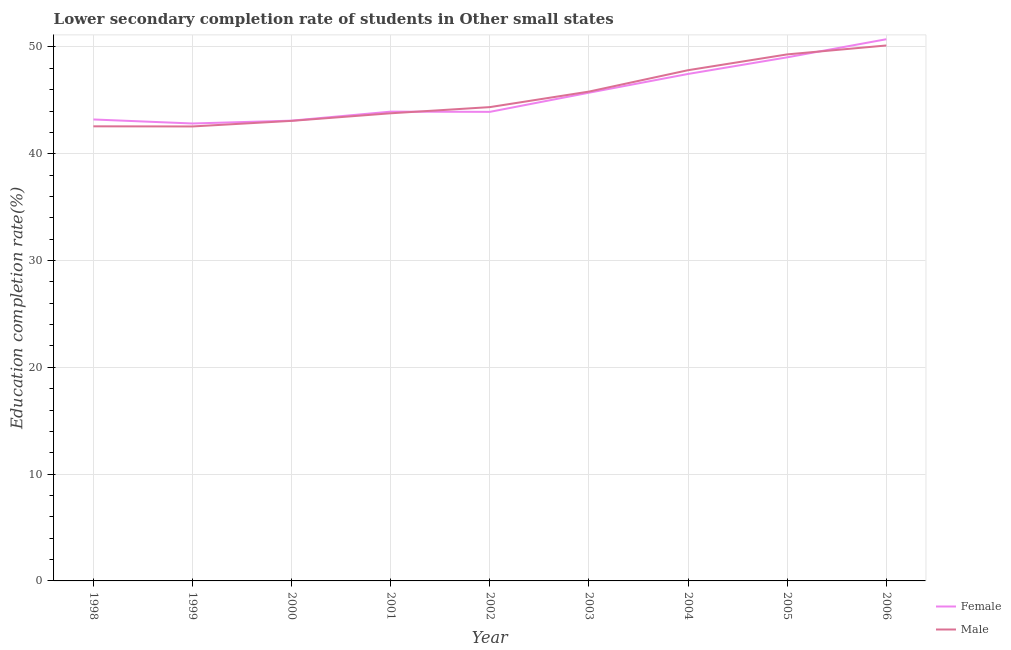How many different coloured lines are there?
Provide a succinct answer. 2. Does the line corresponding to education completion rate of female students intersect with the line corresponding to education completion rate of male students?
Make the answer very short. Yes. What is the education completion rate of female students in 1999?
Give a very brief answer. 42.84. Across all years, what is the maximum education completion rate of female students?
Offer a terse response. 50.72. Across all years, what is the minimum education completion rate of female students?
Keep it short and to the point. 42.84. What is the total education completion rate of female students in the graph?
Your answer should be very brief. 409.97. What is the difference between the education completion rate of female students in 2000 and that in 2002?
Make the answer very short. -0.82. What is the difference between the education completion rate of male students in 2003 and the education completion rate of female students in 2002?
Offer a terse response. 1.9. What is the average education completion rate of male students per year?
Your answer should be compact. 45.5. In the year 1999, what is the difference between the education completion rate of female students and education completion rate of male students?
Offer a terse response. 0.28. In how many years, is the education completion rate of female students greater than 40 %?
Ensure brevity in your answer.  9. What is the ratio of the education completion rate of male students in 2002 to that in 2004?
Provide a short and direct response. 0.93. Is the education completion rate of male students in 1998 less than that in 2004?
Provide a succinct answer. Yes. Is the difference between the education completion rate of male students in 2000 and 2001 greater than the difference between the education completion rate of female students in 2000 and 2001?
Make the answer very short. Yes. What is the difference between the highest and the second highest education completion rate of female students?
Provide a short and direct response. 1.69. What is the difference between the highest and the lowest education completion rate of female students?
Your answer should be compact. 7.89. In how many years, is the education completion rate of female students greater than the average education completion rate of female students taken over all years?
Ensure brevity in your answer.  4. Does the education completion rate of male students monotonically increase over the years?
Keep it short and to the point. No. Is the education completion rate of male students strictly greater than the education completion rate of female students over the years?
Offer a very short reply. No. Is the education completion rate of male students strictly less than the education completion rate of female students over the years?
Keep it short and to the point. No. Where does the legend appear in the graph?
Offer a terse response. Bottom right. What is the title of the graph?
Offer a very short reply. Lower secondary completion rate of students in Other small states. Does "Register a property" appear as one of the legend labels in the graph?
Ensure brevity in your answer.  No. What is the label or title of the Y-axis?
Give a very brief answer. Education completion rate(%). What is the Education completion rate(%) of Female in 1998?
Make the answer very short. 43.21. What is the Education completion rate(%) of Male in 1998?
Offer a very short reply. 42.57. What is the Education completion rate(%) of Female in 1999?
Give a very brief answer. 42.84. What is the Education completion rate(%) of Male in 1999?
Offer a very short reply. 42.56. What is the Education completion rate(%) of Female in 2000?
Your answer should be compact. 43.1. What is the Education completion rate(%) in Male in 2000?
Your answer should be compact. 43.08. What is the Education completion rate(%) of Female in 2001?
Provide a succinct answer. 43.95. What is the Education completion rate(%) in Male in 2001?
Give a very brief answer. 43.79. What is the Education completion rate(%) in Female in 2002?
Make the answer very short. 43.92. What is the Education completion rate(%) in Male in 2002?
Provide a succinct answer. 44.37. What is the Education completion rate(%) in Female in 2003?
Give a very brief answer. 45.72. What is the Education completion rate(%) of Male in 2003?
Your answer should be very brief. 45.82. What is the Education completion rate(%) in Female in 2004?
Your answer should be very brief. 47.47. What is the Education completion rate(%) of Male in 2004?
Give a very brief answer. 47.83. What is the Education completion rate(%) of Female in 2005?
Ensure brevity in your answer.  49.03. What is the Education completion rate(%) of Male in 2005?
Ensure brevity in your answer.  49.31. What is the Education completion rate(%) of Female in 2006?
Your answer should be compact. 50.72. What is the Education completion rate(%) of Male in 2006?
Your response must be concise. 50.14. Across all years, what is the maximum Education completion rate(%) in Female?
Offer a terse response. 50.72. Across all years, what is the maximum Education completion rate(%) of Male?
Provide a short and direct response. 50.14. Across all years, what is the minimum Education completion rate(%) in Female?
Your answer should be very brief. 42.84. Across all years, what is the minimum Education completion rate(%) of Male?
Provide a succinct answer. 42.56. What is the total Education completion rate(%) of Female in the graph?
Make the answer very short. 409.97. What is the total Education completion rate(%) in Male in the graph?
Ensure brevity in your answer.  409.46. What is the difference between the Education completion rate(%) of Female in 1998 and that in 1999?
Ensure brevity in your answer.  0.38. What is the difference between the Education completion rate(%) of Male in 1998 and that in 1999?
Your answer should be compact. 0.01. What is the difference between the Education completion rate(%) in Female in 1998 and that in 2000?
Your response must be concise. 0.11. What is the difference between the Education completion rate(%) of Male in 1998 and that in 2000?
Ensure brevity in your answer.  -0.51. What is the difference between the Education completion rate(%) of Female in 1998 and that in 2001?
Your answer should be compact. -0.73. What is the difference between the Education completion rate(%) of Male in 1998 and that in 2001?
Offer a very short reply. -1.22. What is the difference between the Education completion rate(%) in Female in 1998 and that in 2002?
Make the answer very short. -0.71. What is the difference between the Education completion rate(%) in Male in 1998 and that in 2002?
Give a very brief answer. -1.8. What is the difference between the Education completion rate(%) of Female in 1998 and that in 2003?
Your answer should be very brief. -2.51. What is the difference between the Education completion rate(%) in Male in 1998 and that in 2003?
Provide a short and direct response. -3.25. What is the difference between the Education completion rate(%) in Female in 1998 and that in 2004?
Offer a terse response. -4.26. What is the difference between the Education completion rate(%) of Male in 1998 and that in 2004?
Provide a succinct answer. -5.26. What is the difference between the Education completion rate(%) of Female in 1998 and that in 2005?
Make the answer very short. -5.82. What is the difference between the Education completion rate(%) of Male in 1998 and that in 2005?
Ensure brevity in your answer.  -6.74. What is the difference between the Education completion rate(%) in Female in 1998 and that in 2006?
Ensure brevity in your answer.  -7.51. What is the difference between the Education completion rate(%) in Male in 1998 and that in 2006?
Give a very brief answer. -7.57. What is the difference between the Education completion rate(%) in Female in 1999 and that in 2000?
Keep it short and to the point. -0.27. What is the difference between the Education completion rate(%) in Male in 1999 and that in 2000?
Make the answer very short. -0.52. What is the difference between the Education completion rate(%) in Female in 1999 and that in 2001?
Offer a very short reply. -1.11. What is the difference between the Education completion rate(%) of Male in 1999 and that in 2001?
Your answer should be compact. -1.23. What is the difference between the Education completion rate(%) in Female in 1999 and that in 2002?
Offer a very short reply. -1.09. What is the difference between the Education completion rate(%) in Male in 1999 and that in 2002?
Your response must be concise. -1.81. What is the difference between the Education completion rate(%) of Female in 1999 and that in 2003?
Your answer should be compact. -2.88. What is the difference between the Education completion rate(%) in Male in 1999 and that in 2003?
Give a very brief answer. -3.26. What is the difference between the Education completion rate(%) in Female in 1999 and that in 2004?
Give a very brief answer. -4.64. What is the difference between the Education completion rate(%) in Male in 1999 and that in 2004?
Make the answer very short. -5.27. What is the difference between the Education completion rate(%) in Female in 1999 and that in 2005?
Your answer should be compact. -6.2. What is the difference between the Education completion rate(%) in Male in 1999 and that in 2005?
Make the answer very short. -6.75. What is the difference between the Education completion rate(%) of Female in 1999 and that in 2006?
Your response must be concise. -7.89. What is the difference between the Education completion rate(%) of Male in 1999 and that in 2006?
Give a very brief answer. -7.58. What is the difference between the Education completion rate(%) in Female in 2000 and that in 2001?
Your answer should be compact. -0.84. What is the difference between the Education completion rate(%) in Male in 2000 and that in 2001?
Your answer should be compact. -0.71. What is the difference between the Education completion rate(%) of Female in 2000 and that in 2002?
Provide a short and direct response. -0.82. What is the difference between the Education completion rate(%) of Male in 2000 and that in 2002?
Offer a terse response. -1.29. What is the difference between the Education completion rate(%) in Female in 2000 and that in 2003?
Your response must be concise. -2.62. What is the difference between the Education completion rate(%) in Male in 2000 and that in 2003?
Offer a terse response. -2.74. What is the difference between the Education completion rate(%) of Female in 2000 and that in 2004?
Offer a terse response. -4.37. What is the difference between the Education completion rate(%) of Male in 2000 and that in 2004?
Provide a succinct answer. -4.75. What is the difference between the Education completion rate(%) in Female in 2000 and that in 2005?
Keep it short and to the point. -5.93. What is the difference between the Education completion rate(%) in Male in 2000 and that in 2005?
Offer a very short reply. -6.22. What is the difference between the Education completion rate(%) in Female in 2000 and that in 2006?
Give a very brief answer. -7.62. What is the difference between the Education completion rate(%) of Male in 2000 and that in 2006?
Provide a short and direct response. -7.06. What is the difference between the Education completion rate(%) in Female in 2001 and that in 2002?
Ensure brevity in your answer.  0.02. What is the difference between the Education completion rate(%) of Male in 2001 and that in 2002?
Your response must be concise. -0.58. What is the difference between the Education completion rate(%) of Female in 2001 and that in 2003?
Your answer should be very brief. -1.77. What is the difference between the Education completion rate(%) of Male in 2001 and that in 2003?
Provide a succinct answer. -2.03. What is the difference between the Education completion rate(%) of Female in 2001 and that in 2004?
Your answer should be compact. -3.53. What is the difference between the Education completion rate(%) of Male in 2001 and that in 2004?
Offer a very short reply. -4.03. What is the difference between the Education completion rate(%) in Female in 2001 and that in 2005?
Ensure brevity in your answer.  -5.09. What is the difference between the Education completion rate(%) in Male in 2001 and that in 2005?
Offer a very short reply. -5.51. What is the difference between the Education completion rate(%) in Female in 2001 and that in 2006?
Give a very brief answer. -6.78. What is the difference between the Education completion rate(%) of Male in 2001 and that in 2006?
Your answer should be compact. -6.35. What is the difference between the Education completion rate(%) of Female in 2002 and that in 2003?
Your answer should be very brief. -1.79. What is the difference between the Education completion rate(%) in Male in 2002 and that in 2003?
Your response must be concise. -1.45. What is the difference between the Education completion rate(%) in Female in 2002 and that in 2004?
Your answer should be very brief. -3.55. What is the difference between the Education completion rate(%) of Male in 2002 and that in 2004?
Provide a succinct answer. -3.46. What is the difference between the Education completion rate(%) of Female in 2002 and that in 2005?
Keep it short and to the point. -5.11. What is the difference between the Education completion rate(%) of Male in 2002 and that in 2005?
Offer a very short reply. -4.94. What is the difference between the Education completion rate(%) of Female in 2002 and that in 2006?
Ensure brevity in your answer.  -6.8. What is the difference between the Education completion rate(%) in Male in 2002 and that in 2006?
Provide a succinct answer. -5.77. What is the difference between the Education completion rate(%) in Female in 2003 and that in 2004?
Your answer should be compact. -1.76. What is the difference between the Education completion rate(%) in Male in 2003 and that in 2004?
Keep it short and to the point. -2. What is the difference between the Education completion rate(%) in Female in 2003 and that in 2005?
Offer a terse response. -3.31. What is the difference between the Education completion rate(%) in Male in 2003 and that in 2005?
Keep it short and to the point. -3.48. What is the difference between the Education completion rate(%) in Female in 2003 and that in 2006?
Offer a very short reply. -5.01. What is the difference between the Education completion rate(%) in Male in 2003 and that in 2006?
Provide a succinct answer. -4.32. What is the difference between the Education completion rate(%) in Female in 2004 and that in 2005?
Provide a succinct answer. -1.56. What is the difference between the Education completion rate(%) of Male in 2004 and that in 2005?
Provide a succinct answer. -1.48. What is the difference between the Education completion rate(%) of Female in 2004 and that in 2006?
Provide a succinct answer. -3.25. What is the difference between the Education completion rate(%) in Male in 2004 and that in 2006?
Offer a very short reply. -2.31. What is the difference between the Education completion rate(%) in Female in 2005 and that in 2006?
Provide a succinct answer. -1.69. What is the difference between the Education completion rate(%) of Male in 2005 and that in 2006?
Provide a short and direct response. -0.84. What is the difference between the Education completion rate(%) of Female in 1998 and the Education completion rate(%) of Male in 1999?
Provide a short and direct response. 0.65. What is the difference between the Education completion rate(%) of Female in 1998 and the Education completion rate(%) of Male in 2000?
Keep it short and to the point. 0.13. What is the difference between the Education completion rate(%) of Female in 1998 and the Education completion rate(%) of Male in 2001?
Offer a terse response. -0.58. What is the difference between the Education completion rate(%) of Female in 1998 and the Education completion rate(%) of Male in 2002?
Your response must be concise. -1.16. What is the difference between the Education completion rate(%) in Female in 1998 and the Education completion rate(%) in Male in 2003?
Ensure brevity in your answer.  -2.61. What is the difference between the Education completion rate(%) in Female in 1998 and the Education completion rate(%) in Male in 2004?
Your answer should be compact. -4.61. What is the difference between the Education completion rate(%) of Female in 1998 and the Education completion rate(%) of Male in 2005?
Offer a terse response. -6.09. What is the difference between the Education completion rate(%) in Female in 1998 and the Education completion rate(%) in Male in 2006?
Offer a very short reply. -6.93. What is the difference between the Education completion rate(%) of Female in 1999 and the Education completion rate(%) of Male in 2000?
Make the answer very short. -0.25. What is the difference between the Education completion rate(%) of Female in 1999 and the Education completion rate(%) of Male in 2001?
Keep it short and to the point. -0.96. What is the difference between the Education completion rate(%) in Female in 1999 and the Education completion rate(%) in Male in 2002?
Offer a very short reply. -1.53. What is the difference between the Education completion rate(%) in Female in 1999 and the Education completion rate(%) in Male in 2003?
Give a very brief answer. -2.99. What is the difference between the Education completion rate(%) of Female in 1999 and the Education completion rate(%) of Male in 2004?
Offer a terse response. -4.99. What is the difference between the Education completion rate(%) of Female in 1999 and the Education completion rate(%) of Male in 2005?
Provide a succinct answer. -6.47. What is the difference between the Education completion rate(%) in Female in 1999 and the Education completion rate(%) in Male in 2006?
Offer a very short reply. -7.31. What is the difference between the Education completion rate(%) in Female in 2000 and the Education completion rate(%) in Male in 2001?
Keep it short and to the point. -0.69. What is the difference between the Education completion rate(%) in Female in 2000 and the Education completion rate(%) in Male in 2002?
Ensure brevity in your answer.  -1.27. What is the difference between the Education completion rate(%) of Female in 2000 and the Education completion rate(%) of Male in 2003?
Give a very brief answer. -2.72. What is the difference between the Education completion rate(%) of Female in 2000 and the Education completion rate(%) of Male in 2004?
Provide a succinct answer. -4.73. What is the difference between the Education completion rate(%) of Female in 2000 and the Education completion rate(%) of Male in 2005?
Make the answer very short. -6.2. What is the difference between the Education completion rate(%) of Female in 2000 and the Education completion rate(%) of Male in 2006?
Provide a succinct answer. -7.04. What is the difference between the Education completion rate(%) of Female in 2001 and the Education completion rate(%) of Male in 2002?
Provide a succinct answer. -0.42. What is the difference between the Education completion rate(%) of Female in 2001 and the Education completion rate(%) of Male in 2003?
Ensure brevity in your answer.  -1.88. What is the difference between the Education completion rate(%) in Female in 2001 and the Education completion rate(%) in Male in 2004?
Your response must be concise. -3.88. What is the difference between the Education completion rate(%) in Female in 2001 and the Education completion rate(%) in Male in 2005?
Offer a very short reply. -5.36. What is the difference between the Education completion rate(%) in Female in 2001 and the Education completion rate(%) in Male in 2006?
Keep it short and to the point. -6.2. What is the difference between the Education completion rate(%) in Female in 2002 and the Education completion rate(%) in Male in 2003?
Provide a short and direct response. -1.9. What is the difference between the Education completion rate(%) in Female in 2002 and the Education completion rate(%) in Male in 2004?
Provide a short and direct response. -3.9. What is the difference between the Education completion rate(%) in Female in 2002 and the Education completion rate(%) in Male in 2005?
Give a very brief answer. -5.38. What is the difference between the Education completion rate(%) of Female in 2002 and the Education completion rate(%) of Male in 2006?
Give a very brief answer. -6.22. What is the difference between the Education completion rate(%) of Female in 2003 and the Education completion rate(%) of Male in 2004?
Ensure brevity in your answer.  -2.11. What is the difference between the Education completion rate(%) in Female in 2003 and the Education completion rate(%) in Male in 2005?
Give a very brief answer. -3.59. What is the difference between the Education completion rate(%) in Female in 2003 and the Education completion rate(%) in Male in 2006?
Your answer should be very brief. -4.42. What is the difference between the Education completion rate(%) of Female in 2004 and the Education completion rate(%) of Male in 2005?
Offer a terse response. -1.83. What is the difference between the Education completion rate(%) in Female in 2004 and the Education completion rate(%) in Male in 2006?
Your answer should be compact. -2.67. What is the difference between the Education completion rate(%) in Female in 2005 and the Education completion rate(%) in Male in 2006?
Offer a very short reply. -1.11. What is the average Education completion rate(%) of Female per year?
Your response must be concise. 45.55. What is the average Education completion rate(%) of Male per year?
Offer a very short reply. 45.5. In the year 1998, what is the difference between the Education completion rate(%) in Female and Education completion rate(%) in Male?
Keep it short and to the point. 0.64. In the year 1999, what is the difference between the Education completion rate(%) of Female and Education completion rate(%) of Male?
Provide a short and direct response. 0.28. In the year 2000, what is the difference between the Education completion rate(%) of Female and Education completion rate(%) of Male?
Keep it short and to the point. 0.02. In the year 2001, what is the difference between the Education completion rate(%) in Female and Education completion rate(%) in Male?
Provide a short and direct response. 0.15. In the year 2002, what is the difference between the Education completion rate(%) in Female and Education completion rate(%) in Male?
Provide a succinct answer. -0.44. In the year 2003, what is the difference between the Education completion rate(%) of Female and Education completion rate(%) of Male?
Offer a terse response. -0.1. In the year 2004, what is the difference between the Education completion rate(%) of Female and Education completion rate(%) of Male?
Offer a very short reply. -0.35. In the year 2005, what is the difference between the Education completion rate(%) in Female and Education completion rate(%) in Male?
Keep it short and to the point. -0.27. In the year 2006, what is the difference between the Education completion rate(%) of Female and Education completion rate(%) of Male?
Your answer should be compact. 0.58. What is the ratio of the Education completion rate(%) in Female in 1998 to that in 1999?
Your answer should be very brief. 1.01. What is the ratio of the Education completion rate(%) of Female in 1998 to that in 2001?
Provide a short and direct response. 0.98. What is the ratio of the Education completion rate(%) of Male in 1998 to that in 2001?
Your answer should be very brief. 0.97. What is the ratio of the Education completion rate(%) of Female in 1998 to that in 2002?
Keep it short and to the point. 0.98. What is the ratio of the Education completion rate(%) of Male in 1998 to that in 2002?
Offer a very short reply. 0.96. What is the ratio of the Education completion rate(%) in Female in 1998 to that in 2003?
Your response must be concise. 0.95. What is the ratio of the Education completion rate(%) in Male in 1998 to that in 2003?
Make the answer very short. 0.93. What is the ratio of the Education completion rate(%) of Female in 1998 to that in 2004?
Provide a short and direct response. 0.91. What is the ratio of the Education completion rate(%) in Male in 1998 to that in 2004?
Your response must be concise. 0.89. What is the ratio of the Education completion rate(%) in Female in 1998 to that in 2005?
Provide a short and direct response. 0.88. What is the ratio of the Education completion rate(%) in Male in 1998 to that in 2005?
Provide a short and direct response. 0.86. What is the ratio of the Education completion rate(%) in Female in 1998 to that in 2006?
Make the answer very short. 0.85. What is the ratio of the Education completion rate(%) in Male in 1998 to that in 2006?
Provide a succinct answer. 0.85. What is the ratio of the Education completion rate(%) of Female in 1999 to that in 2000?
Keep it short and to the point. 0.99. What is the ratio of the Education completion rate(%) of Male in 1999 to that in 2000?
Offer a very short reply. 0.99. What is the ratio of the Education completion rate(%) in Female in 1999 to that in 2001?
Offer a terse response. 0.97. What is the ratio of the Education completion rate(%) in Male in 1999 to that in 2001?
Offer a very short reply. 0.97. What is the ratio of the Education completion rate(%) of Female in 1999 to that in 2002?
Provide a succinct answer. 0.98. What is the ratio of the Education completion rate(%) of Male in 1999 to that in 2002?
Keep it short and to the point. 0.96. What is the ratio of the Education completion rate(%) in Female in 1999 to that in 2003?
Give a very brief answer. 0.94. What is the ratio of the Education completion rate(%) in Male in 1999 to that in 2003?
Give a very brief answer. 0.93. What is the ratio of the Education completion rate(%) in Female in 1999 to that in 2004?
Offer a terse response. 0.9. What is the ratio of the Education completion rate(%) in Male in 1999 to that in 2004?
Offer a very short reply. 0.89. What is the ratio of the Education completion rate(%) in Female in 1999 to that in 2005?
Provide a short and direct response. 0.87. What is the ratio of the Education completion rate(%) of Male in 1999 to that in 2005?
Your response must be concise. 0.86. What is the ratio of the Education completion rate(%) of Female in 1999 to that in 2006?
Offer a very short reply. 0.84. What is the ratio of the Education completion rate(%) in Male in 1999 to that in 2006?
Make the answer very short. 0.85. What is the ratio of the Education completion rate(%) in Female in 2000 to that in 2001?
Provide a short and direct response. 0.98. What is the ratio of the Education completion rate(%) in Male in 2000 to that in 2001?
Your answer should be compact. 0.98. What is the ratio of the Education completion rate(%) of Female in 2000 to that in 2002?
Offer a terse response. 0.98. What is the ratio of the Education completion rate(%) in Male in 2000 to that in 2002?
Ensure brevity in your answer.  0.97. What is the ratio of the Education completion rate(%) in Female in 2000 to that in 2003?
Give a very brief answer. 0.94. What is the ratio of the Education completion rate(%) of Male in 2000 to that in 2003?
Offer a very short reply. 0.94. What is the ratio of the Education completion rate(%) in Female in 2000 to that in 2004?
Offer a very short reply. 0.91. What is the ratio of the Education completion rate(%) of Male in 2000 to that in 2004?
Make the answer very short. 0.9. What is the ratio of the Education completion rate(%) in Female in 2000 to that in 2005?
Your answer should be compact. 0.88. What is the ratio of the Education completion rate(%) of Male in 2000 to that in 2005?
Make the answer very short. 0.87. What is the ratio of the Education completion rate(%) in Female in 2000 to that in 2006?
Your response must be concise. 0.85. What is the ratio of the Education completion rate(%) in Male in 2000 to that in 2006?
Offer a very short reply. 0.86. What is the ratio of the Education completion rate(%) of Female in 2001 to that in 2002?
Make the answer very short. 1. What is the ratio of the Education completion rate(%) in Female in 2001 to that in 2003?
Ensure brevity in your answer.  0.96. What is the ratio of the Education completion rate(%) in Male in 2001 to that in 2003?
Give a very brief answer. 0.96. What is the ratio of the Education completion rate(%) in Female in 2001 to that in 2004?
Your response must be concise. 0.93. What is the ratio of the Education completion rate(%) of Male in 2001 to that in 2004?
Your response must be concise. 0.92. What is the ratio of the Education completion rate(%) of Female in 2001 to that in 2005?
Your answer should be very brief. 0.9. What is the ratio of the Education completion rate(%) in Male in 2001 to that in 2005?
Ensure brevity in your answer.  0.89. What is the ratio of the Education completion rate(%) in Female in 2001 to that in 2006?
Make the answer very short. 0.87. What is the ratio of the Education completion rate(%) in Male in 2001 to that in 2006?
Your answer should be compact. 0.87. What is the ratio of the Education completion rate(%) of Female in 2002 to that in 2003?
Your response must be concise. 0.96. What is the ratio of the Education completion rate(%) of Male in 2002 to that in 2003?
Your answer should be very brief. 0.97. What is the ratio of the Education completion rate(%) of Female in 2002 to that in 2004?
Provide a short and direct response. 0.93. What is the ratio of the Education completion rate(%) in Male in 2002 to that in 2004?
Your answer should be compact. 0.93. What is the ratio of the Education completion rate(%) of Female in 2002 to that in 2005?
Ensure brevity in your answer.  0.9. What is the ratio of the Education completion rate(%) in Male in 2002 to that in 2005?
Provide a succinct answer. 0.9. What is the ratio of the Education completion rate(%) of Female in 2002 to that in 2006?
Offer a terse response. 0.87. What is the ratio of the Education completion rate(%) of Male in 2002 to that in 2006?
Your response must be concise. 0.88. What is the ratio of the Education completion rate(%) of Male in 2003 to that in 2004?
Your answer should be compact. 0.96. What is the ratio of the Education completion rate(%) in Female in 2003 to that in 2005?
Give a very brief answer. 0.93. What is the ratio of the Education completion rate(%) of Male in 2003 to that in 2005?
Your answer should be compact. 0.93. What is the ratio of the Education completion rate(%) of Female in 2003 to that in 2006?
Offer a very short reply. 0.9. What is the ratio of the Education completion rate(%) in Male in 2003 to that in 2006?
Provide a short and direct response. 0.91. What is the ratio of the Education completion rate(%) in Female in 2004 to that in 2005?
Make the answer very short. 0.97. What is the ratio of the Education completion rate(%) in Female in 2004 to that in 2006?
Give a very brief answer. 0.94. What is the ratio of the Education completion rate(%) in Male in 2004 to that in 2006?
Make the answer very short. 0.95. What is the ratio of the Education completion rate(%) of Female in 2005 to that in 2006?
Your answer should be very brief. 0.97. What is the ratio of the Education completion rate(%) of Male in 2005 to that in 2006?
Give a very brief answer. 0.98. What is the difference between the highest and the second highest Education completion rate(%) in Female?
Provide a succinct answer. 1.69. What is the difference between the highest and the second highest Education completion rate(%) in Male?
Your answer should be compact. 0.84. What is the difference between the highest and the lowest Education completion rate(%) in Female?
Give a very brief answer. 7.89. What is the difference between the highest and the lowest Education completion rate(%) of Male?
Your answer should be very brief. 7.58. 